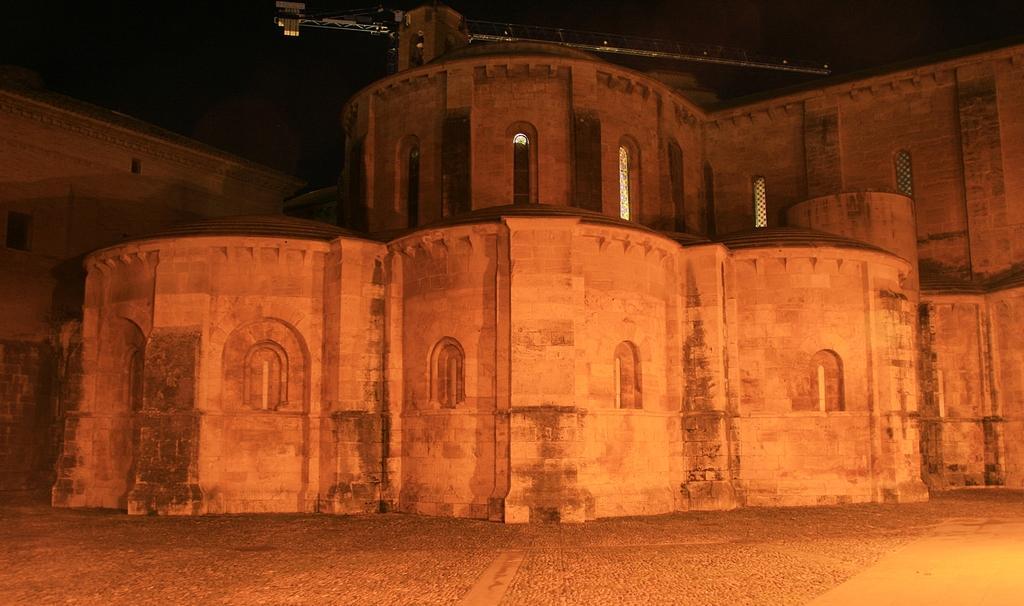Please provide a concise description of this image. There are buildings having windows on the ground. And the background is dark in color. 